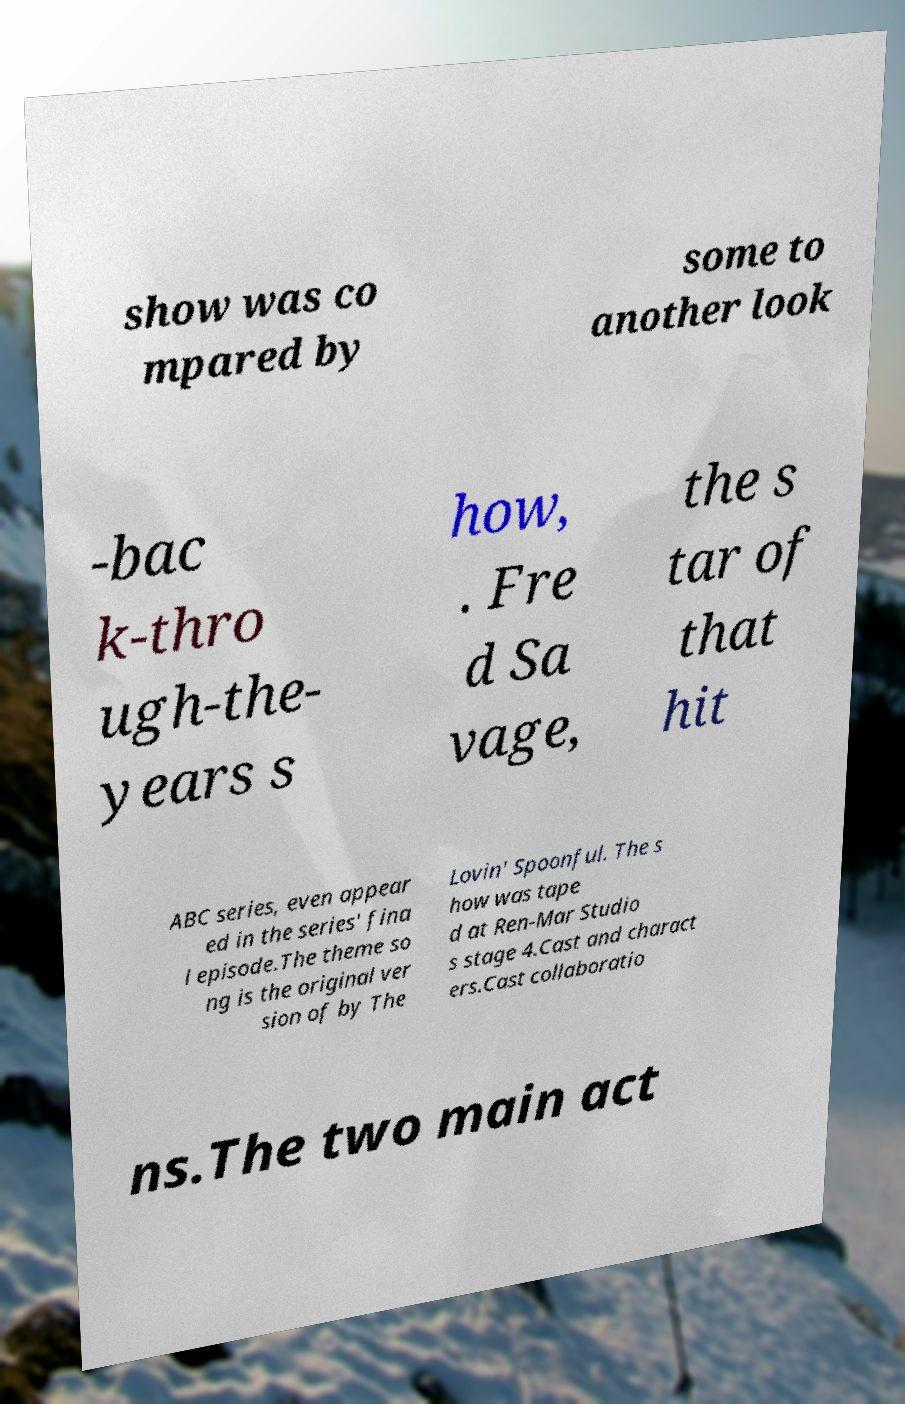What messages or text are displayed in this image? I need them in a readable, typed format. show was co mpared by some to another look -bac k-thro ugh-the- years s how, . Fre d Sa vage, the s tar of that hit ABC series, even appear ed in the series' fina l episode.The theme so ng is the original ver sion of by The Lovin' Spoonful. The s how was tape d at Ren-Mar Studio s stage 4.Cast and charact ers.Cast collaboratio ns.The two main act 